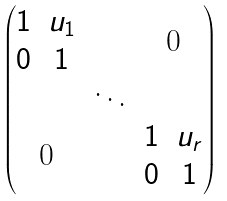Convert formula to latex. <formula><loc_0><loc_0><loc_500><loc_500>\begin{pmatrix} \begin{matrix} 1 & u _ { 1 } \\ 0 & 1 \end{matrix} & & $ 0 $ \\ & \ddots & \\ $ 0 $ & & \begin{matrix} 1 & u _ { r } \\ 0 & 1 \end{matrix} \end{pmatrix}</formula> 